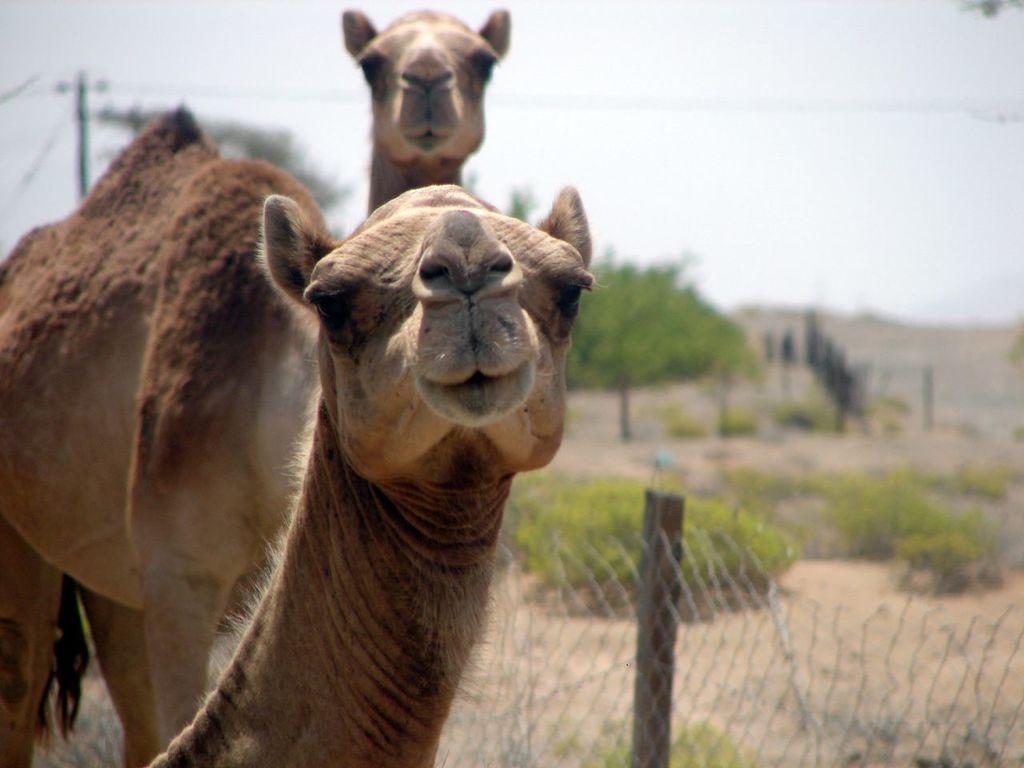Describe this image in one or two sentences. In this image, we can see animals and in the background, there are trees and we can see a pole and there are wires and there is a fence. At the top, there is sky. 